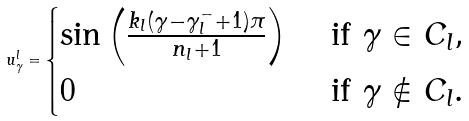<formula> <loc_0><loc_0><loc_500><loc_500>u ^ { l } _ { \gamma } = \begin{cases} \sin \left ( \frac { k _ { l } ( \gamma - \gamma ^ { - } _ { l } + 1 ) \pi } { n _ { l } + 1 } \right ) & \text { if } \gamma \in C _ { l } , \\ 0 & \text { if } \gamma \not \in C _ { l } . \end{cases}</formula> 